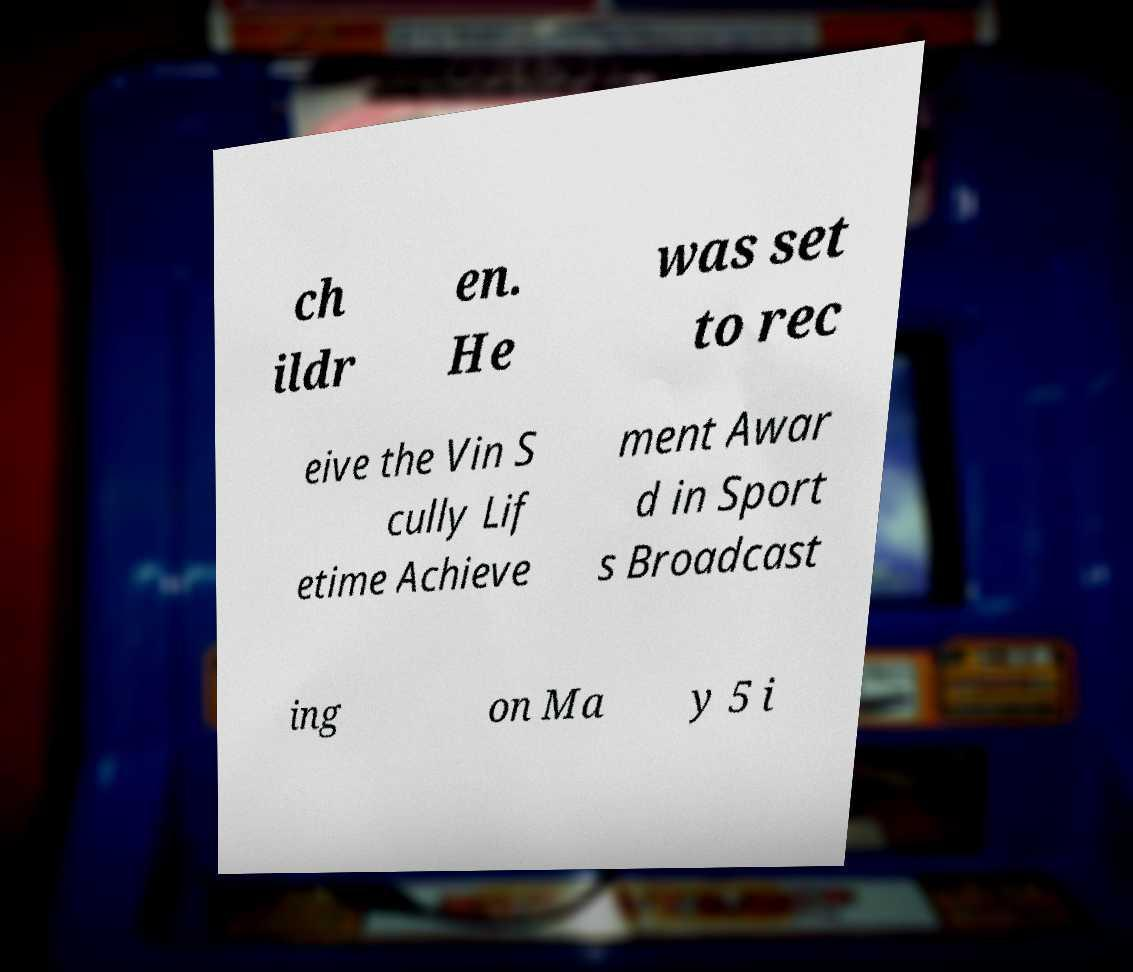For documentation purposes, I need the text within this image transcribed. Could you provide that? ch ildr en. He was set to rec eive the Vin S cully Lif etime Achieve ment Awar d in Sport s Broadcast ing on Ma y 5 i 